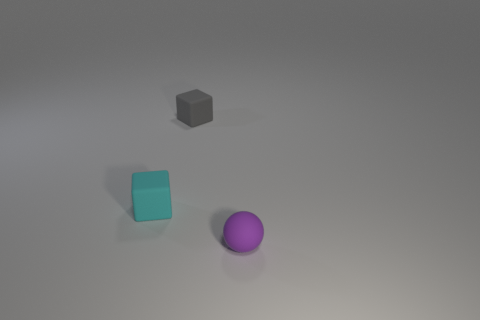What textures do the objects appear to have? The textures of the objects are not highly detailed in the image, but the surfaces of the cyan cube and the purple sphere have a slightly matte appearance, while the gray block appears to have a neutral, possibly plastic-like texture. 